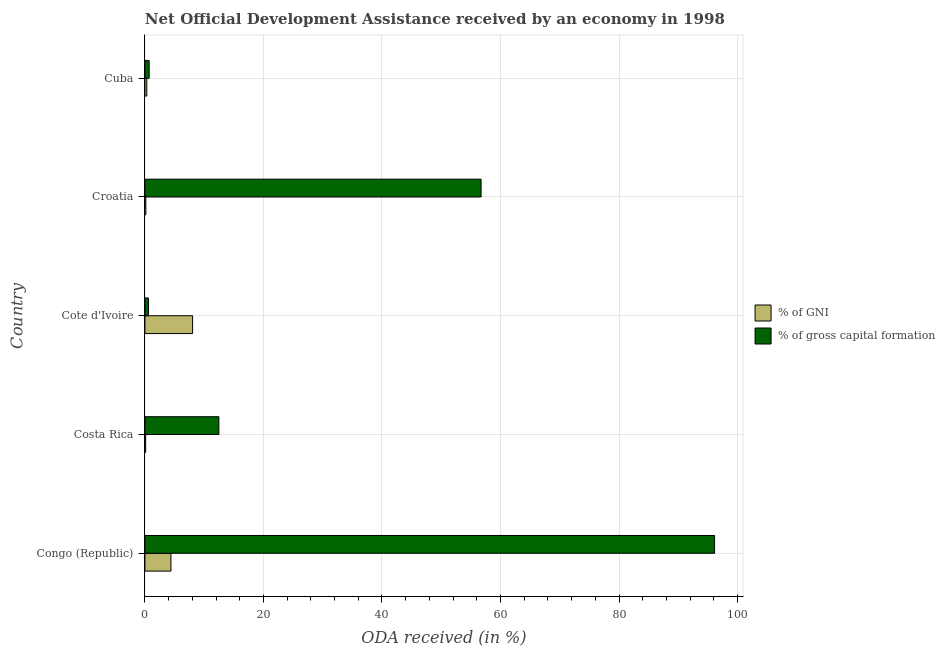How many different coloured bars are there?
Your answer should be very brief. 2. How many groups of bars are there?
Your answer should be very brief. 5. Are the number of bars per tick equal to the number of legend labels?
Give a very brief answer. Yes. How many bars are there on the 3rd tick from the bottom?
Provide a short and direct response. 2. What is the label of the 2nd group of bars from the top?
Make the answer very short. Croatia. In how many cases, is the number of bars for a given country not equal to the number of legend labels?
Keep it short and to the point. 0. What is the oda received as percentage of gross capital formation in Cote d'Ivoire?
Ensure brevity in your answer.  0.59. Across all countries, what is the maximum oda received as percentage of gross capital formation?
Your answer should be compact. 96.12. Across all countries, what is the minimum oda received as percentage of gni?
Make the answer very short. 0.13. In which country was the oda received as percentage of gross capital formation maximum?
Offer a terse response. Congo (Republic). In which country was the oda received as percentage of gross capital formation minimum?
Give a very brief answer. Cote d'Ivoire. What is the total oda received as percentage of gni in the graph?
Ensure brevity in your answer.  13.03. What is the difference between the oda received as percentage of gross capital formation in Congo (Republic) and that in Costa Rica?
Keep it short and to the point. 83.64. What is the difference between the oda received as percentage of gni in Croatia and the oda received as percentage of gross capital formation in Cote d'Ivoire?
Make the answer very short. -0.44. What is the average oda received as percentage of gross capital formation per country?
Make the answer very short. 33.32. What is the difference between the oda received as percentage of gross capital formation and oda received as percentage of gni in Cuba?
Provide a succinct answer. 0.4. In how many countries, is the oda received as percentage of gross capital formation greater than 40 %?
Give a very brief answer. 2. What is the ratio of the oda received as percentage of gni in Congo (Republic) to that in Cuba?
Offer a very short reply. 13.86. Is the oda received as percentage of gross capital formation in Congo (Republic) less than that in Costa Rica?
Your answer should be compact. No. Is the difference between the oda received as percentage of gni in Congo (Republic) and Costa Rica greater than the difference between the oda received as percentage of gross capital formation in Congo (Republic) and Costa Rica?
Provide a succinct answer. No. What is the difference between the highest and the second highest oda received as percentage of gross capital formation?
Ensure brevity in your answer.  39.4. What is the difference between the highest and the lowest oda received as percentage of gross capital formation?
Your response must be concise. 95.52. In how many countries, is the oda received as percentage of gross capital formation greater than the average oda received as percentage of gross capital formation taken over all countries?
Make the answer very short. 2. Is the sum of the oda received as percentage of gross capital formation in Costa Rica and Cuba greater than the maximum oda received as percentage of gni across all countries?
Ensure brevity in your answer.  Yes. What does the 2nd bar from the top in Cote d'Ivoire represents?
Keep it short and to the point. % of GNI. What does the 2nd bar from the bottom in Croatia represents?
Provide a succinct answer. % of gross capital formation. Are all the bars in the graph horizontal?
Your response must be concise. Yes. How many countries are there in the graph?
Provide a short and direct response. 5. Are the values on the major ticks of X-axis written in scientific E-notation?
Offer a terse response. No. Does the graph contain grids?
Your answer should be compact. Yes. Where does the legend appear in the graph?
Make the answer very short. Center right. How many legend labels are there?
Make the answer very short. 2. How are the legend labels stacked?
Make the answer very short. Vertical. What is the title of the graph?
Your answer should be very brief. Net Official Development Assistance received by an economy in 1998. What is the label or title of the X-axis?
Provide a succinct answer. ODA received (in %). What is the ODA received (in %) in % of GNI in Congo (Republic)?
Provide a succinct answer. 4.39. What is the ODA received (in %) of % of gross capital formation in Congo (Republic)?
Provide a succinct answer. 96.12. What is the ODA received (in %) in % of GNI in Costa Rica?
Provide a succinct answer. 0.13. What is the ODA received (in %) of % of gross capital formation in Costa Rica?
Provide a short and direct response. 12.48. What is the ODA received (in %) of % of GNI in Cote d'Ivoire?
Provide a short and direct response. 8.05. What is the ODA received (in %) of % of gross capital formation in Cote d'Ivoire?
Provide a short and direct response. 0.59. What is the ODA received (in %) in % of GNI in Croatia?
Keep it short and to the point. 0.16. What is the ODA received (in %) of % of gross capital formation in Croatia?
Provide a short and direct response. 56.72. What is the ODA received (in %) in % of GNI in Cuba?
Keep it short and to the point. 0.32. What is the ODA received (in %) in % of gross capital formation in Cuba?
Ensure brevity in your answer.  0.72. Across all countries, what is the maximum ODA received (in %) in % of GNI?
Keep it short and to the point. 8.05. Across all countries, what is the maximum ODA received (in %) in % of gross capital formation?
Make the answer very short. 96.12. Across all countries, what is the minimum ODA received (in %) of % of GNI?
Give a very brief answer. 0.13. Across all countries, what is the minimum ODA received (in %) in % of gross capital formation?
Your response must be concise. 0.59. What is the total ODA received (in %) in % of GNI in the graph?
Ensure brevity in your answer.  13.03. What is the total ODA received (in %) of % of gross capital formation in the graph?
Make the answer very short. 166.62. What is the difference between the ODA received (in %) of % of GNI in Congo (Republic) and that in Costa Rica?
Make the answer very short. 4.26. What is the difference between the ODA received (in %) of % of gross capital formation in Congo (Republic) and that in Costa Rica?
Your answer should be compact. 83.64. What is the difference between the ODA received (in %) of % of GNI in Congo (Republic) and that in Cote d'Ivoire?
Offer a terse response. -3.66. What is the difference between the ODA received (in %) in % of gross capital formation in Congo (Republic) and that in Cote d'Ivoire?
Keep it short and to the point. 95.52. What is the difference between the ODA received (in %) in % of GNI in Congo (Republic) and that in Croatia?
Ensure brevity in your answer.  4.23. What is the difference between the ODA received (in %) of % of gross capital formation in Congo (Republic) and that in Croatia?
Provide a short and direct response. 39.4. What is the difference between the ODA received (in %) of % of GNI in Congo (Republic) and that in Cuba?
Keep it short and to the point. 4.07. What is the difference between the ODA received (in %) of % of gross capital formation in Congo (Republic) and that in Cuba?
Offer a terse response. 95.4. What is the difference between the ODA received (in %) of % of GNI in Costa Rica and that in Cote d'Ivoire?
Your answer should be very brief. -7.92. What is the difference between the ODA received (in %) in % of gross capital formation in Costa Rica and that in Cote d'Ivoire?
Ensure brevity in your answer.  11.89. What is the difference between the ODA received (in %) in % of GNI in Costa Rica and that in Croatia?
Your response must be concise. -0.03. What is the difference between the ODA received (in %) of % of gross capital formation in Costa Rica and that in Croatia?
Make the answer very short. -44.24. What is the difference between the ODA received (in %) in % of GNI in Costa Rica and that in Cuba?
Keep it short and to the point. -0.19. What is the difference between the ODA received (in %) of % of gross capital formation in Costa Rica and that in Cuba?
Your answer should be compact. 11.76. What is the difference between the ODA received (in %) in % of GNI in Cote d'Ivoire and that in Croatia?
Your answer should be compact. 7.89. What is the difference between the ODA received (in %) in % of gross capital formation in Cote d'Ivoire and that in Croatia?
Provide a succinct answer. -56.13. What is the difference between the ODA received (in %) in % of GNI in Cote d'Ivoire and that in Cuba?
Your answer should be very brief. 7.73. What is the difference between the ODA received (in %) of % of gross capital formation in Cote d'Ivoire and that in Cuba?
Provide a succinct answer. -0.12. What is the difference between the ODA received (in %) in % of GNI in Croatia and that in Cuba?
Your answer should be very brief. -0.16. What is the difference between the ODA received (in %) of % of gross capital formation in Croatia and that in Cuba?
Offer a terse response. 56. What is the difference between the ODA received (in %) in % of GNI in Congo (Republic) and the ODA received (in %) in % of gross capital formation in Costa Rica?
Make the answer very short. -8.09. What is the difference between the ODA received (in %) of % of GNI in Congo (Republic) and the ODA received (in %) of % of gross capital formation in Cote d'Ivoire?
Offer a very short reply. 3.8. What is the difference between the ODA received (in %) of % of GNI in Congo (Republic) and the ODA received (in %) of % of gross capital formation in Croatia?
Your answer should be very brief. -52.33. What is the difference between the ODA received (in %) of % of GNI in Congo (Republic) and the ODA received (in %) of % of gross capital formation in Cuba?
Your answer should be compact. 3.67. What is the difference between the ODA received (in %) in % of GNI in Costa Rica and the ODA received (in %) in % of gross capital formation in Cote d'Ivoire?
Provide a succinct answer. -0.47. What is the difference between the ODA received (in %) of % of GNI in Costa Rica and the ODA received (in %) of % of gross capital formation in Croatia?
Your response must be concise. -56.59. What is the difference between the ODA received (in %) in % of GNI in Costa Rica and the ODA received (in %) in % of gross capital formation in Cuba?
Provide a short and direct response. -0.59. What is the difference between the ODA received (in %) of % of GNI in Cote d'Ivoire and the ODA received (in %) of % of gross capital formation in Croatia?
Keep it short and to the point. -48.67. What is the difference between the ODA received (in %) in % of GNI in Cote d'Ivoire and the ODA received (in %) in % of gross capital formation in Cuba?
Your answer should be compact. 7.33. What is the difference between the ODA received (in %) in % of GNI in Croatia and the ODA received (in %) in % of gross capital formation in Cuba?
Make the answer very short. -0.56. What is the average ODA received (in %) in % of GNI per country?
Offer a terse response. 2.61. What is the average ODA received (in %) in % of gross capital formation per country?
Your answer should be compact. 33.32. What is the difference between the ODA received (in %) of % of GNI and ODA received (in %) of % of gross capital formation in Congo (Republic)?
Your response must be concise. -91.73. What is the difference between the ODA received (in %) in % of GNI and ODA received (in %) in % of gross capital formation in Costa Rica?
Your response must be concise. -12.35. What is the difference between the ODA received (in %) in % of GNI and ODA received (in %) in % of gross capital formation in Cote d'Ivoire?
Your answer should be compact. 7.45. What is the difference between the ODA received (in %) of % of GNI and ODA received (in %) of % of gross capital formation in Croatia?
Provide a short and direct response. -56.56. What is the ratio of the ODA received (in %) in % of GNI in Congo (Republic) to that in Costa Rica?
Give a very brief answer. 35.02. What is the ratio of the ODA received (in %) of % of gross capital formation in Congo (Republic) to that in Costa Rica?
Provide a short and direct response. 7.7. What is the ratio of the ODA received (in %) of % of GNI in Congo (Republic) to that in Cote d'Ivoire?
Your answer should be very brief. 0.55. What is the ratio of the ODA received (in %) of % of gross capital formation in Congo (Republic) to that in Cote d'Ivoire?
Offer a very short reply. 162.25. What is the ratio of the ODA received (in %) in % of GNI in Congo (Republic) to that in Croatia?
Offer a very short reply. 28.17. What is the ratio of the ODA received (in %) of % of gross capital formation in Congo (Republic) to that in Croatia?
Offer a terse response. 1.69. What is the ratio of the ODA received (in %) of % of GNI in Congo (Republic) to that in Cuba?
Your answer should be very brief. 13.86. What is the ratio of the ODA received (in %) in % of gross capital formation in Congo (Republic) to that in Cuba?
Your answer should be compact. 134.12. What is the ratio of the ODA received (in %) in % of GNI in Costa Rica to that in Cote d'Ivoire?
Provide a short and direct response. 0.02. What is the ratio of the ODA received (in %) in % of gross capital formation in Costa Rica to that in Cote d'Ivoire?
Provide a short and direct response. 21.06. What is the ratio of the ODA received (in %) in % of GNI in Costa Rica to that in Croatia?
Offer a very short reply. 0.8. What is the ratio of the ODA received (in %) of % of gross capital formation in Costa Rica to that in Croatia?
Keep it short and to the point. 0.22. What is the ratio of the ODA received (in %) of % of GNI in Costa Rica to that in Cuba?
Your answer should be very brief. 0.4. What is the ratio of the ODA received (in %) of % of gross capital formation in Costa Rica to that in Cuba?
Provide a short and direct response. 17.41. What is the ratio of the ODA received (in %) of % of GNI in Cote d'Ivoire to that in Croatia?
Offer a very short reply. 51.62. What is the ratio of the ODA received (in %) of % of gross capital formation in Cote d'Ivoire to that in Croatia?
Ensure brevity in your answer.  0.01. What is the ratio of the ODA received (in %) of % of GNI in Cote d'Ivoire to that in Cuba?
Give a very brief answer. 25.41. What is the ratio of the ODA received (in %) in % of gross capital formation in Cote d'Ivoire to that in Cuba?
Give a very brief answer. 0.83. What is the ratio of the ODA received (in %) of % of GNI in Croatia to that in Cuba?
Keep it short and to the point. 0.49. What is the ratio of the ODA received (in %) of % of gross capital formation in Croatia to that in Cuba?
Your answer should be compact. 79.14. What is the difference between the highest and the second highest ODA received (in %) in % of GNI?
Your response must be concise. 3.66. What is the difference between the highest and the second highest ODA received (in %) in % of gross capital formation?
Offer a terse response. 39.4. What is the difference between the highest and the lowest ODA received (in %) in % of GNI?
Offer a terse response. 7.92. What is the difference between the highest and the lowest ODA received (in %) in % of gross capital formation?
Provide a succinct answer. 95.52. 